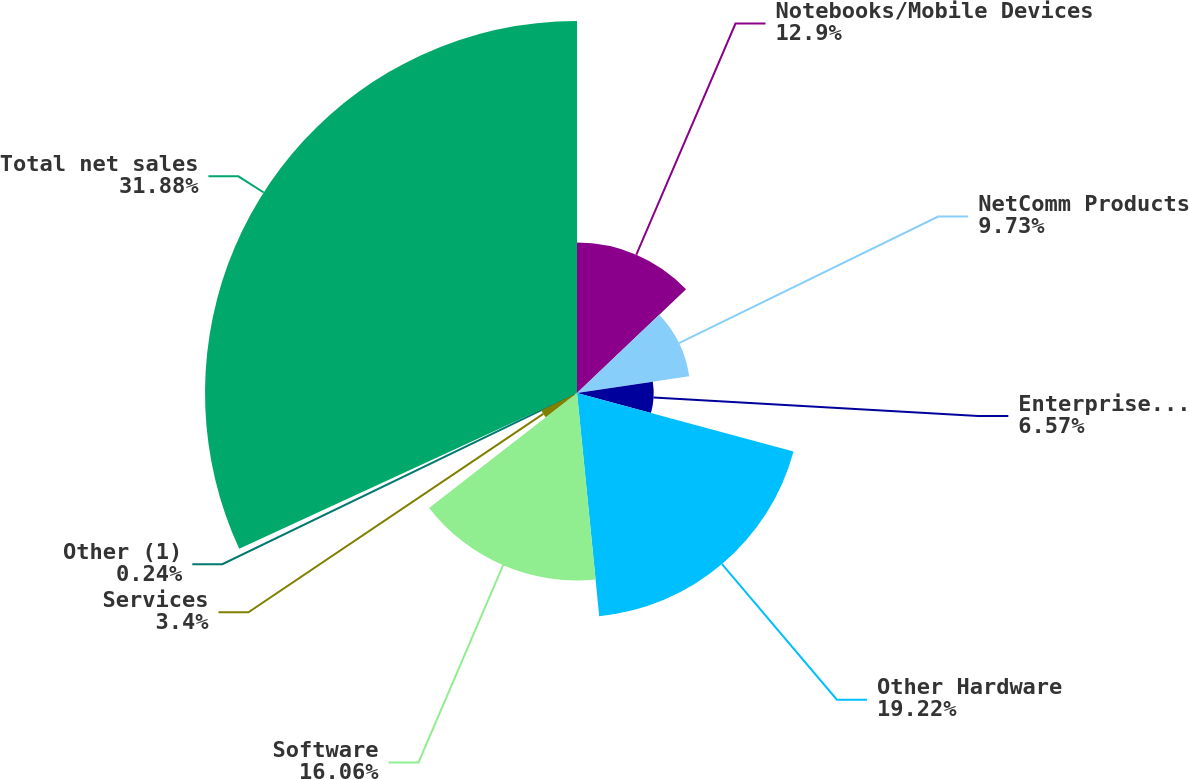Convert chart to OTSL. <chart><loc_0><loc_0><loc_500><loc_500><pie_chart><fcel>Notebooks/Mobile Devices<fcel>NetComm Products<fcel>Enterprise and Data Storage<fcel>Other Hardware<fcel>Software<fcel>Services<fcel>Other (1)<fcel>Total net sales<nl><fcel>12.9%<fcel>9.73%<fcel>6.57%<fcel>19.22%<fcel>16.06%<fcel>3.4%<fcel>0.24%<fcel>31.88%<nl></chart> 